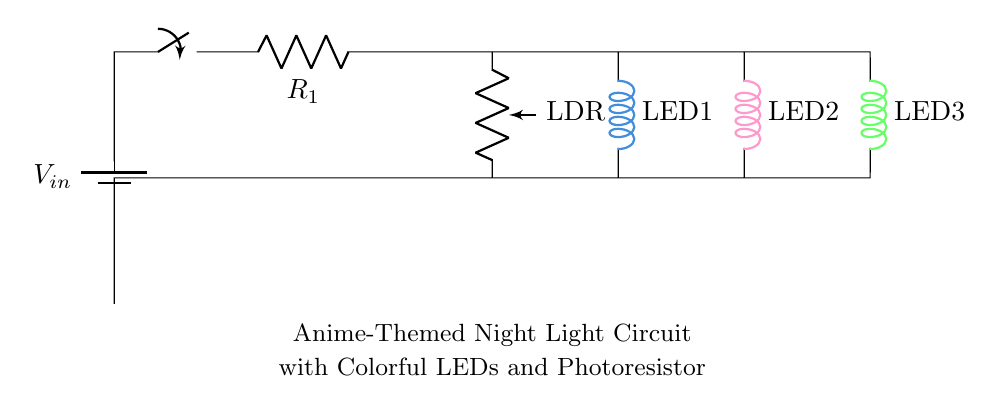What type of resistor is used in this circuit? The circuit uses a photoresistor (LDR), which changes its resistance based on the amount of light it receives. This affects the operation of the circuit, allowing it to react to ambient lighting conditions.
Answer: LDR How many LEDs are present in this circuit? By observing the circuit diagram, it is clear that there are three LEDs connected in parallel to the power supply. Each LED is identified as LED1, LED2, and LED3.
Answer: 3 What is the purpose of the switch in this circuit? The switch is used to control the flow of current from the battery to the rest of the circuit. By opening or closing the switch, the user can turn the entire circuit on or off, effectively controlling the night light.
Answer: Control What happens to the LEDs when the light level increases? As the ambient light increases, the resistance of the photoresistor decreases, allowing more current to flow through the circuit. This can result in the LEDs becoming dimmer or turning off, depending on the specific design of the circuit.
Answer: Dims or off Which color is associated with LED1? The circuit diagram indicates that LED1 is connected in the path marked with the color defined as anime blue, confirming its associated color when it lights up.
Answer: Anime blue 